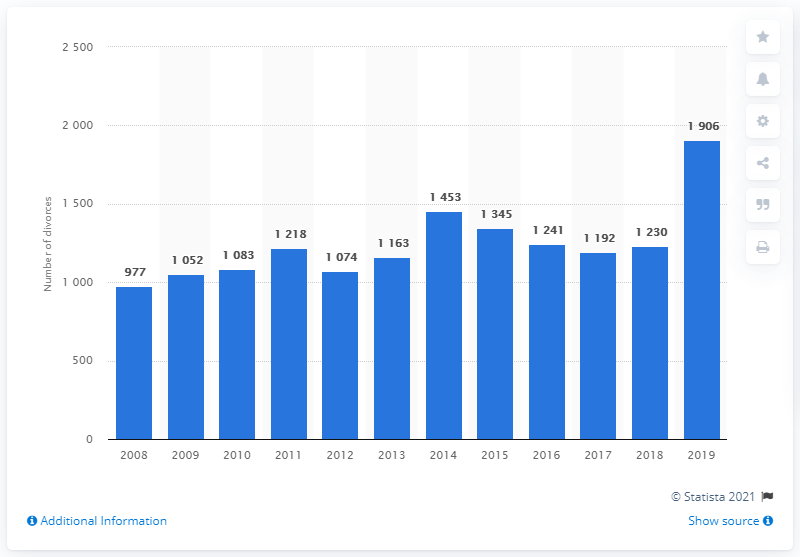Indicate a few pertinent items in this graphic. There were 977 divorces in Luxembourg in the year 2008. 